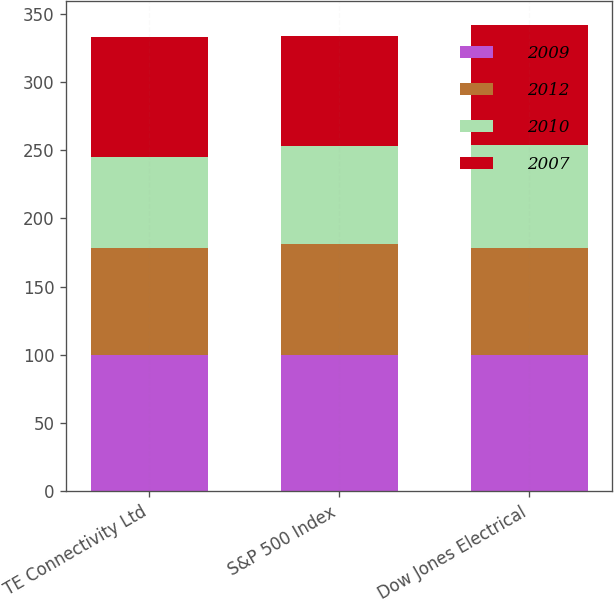Convert chart to OTSL. <chart><loc_0><loc_0><loc_500><loc_500><stacked_bar_chart><ecel><fcel>TE Connectivity Ltd<fcel>S&P 500 Index<fcel>Dow Jones Electrical<nl><fcel>2009<fcel>100<fcel>100<fcel>100<nl><fcel>2012<fcel>78.25<fcel>81.14<fcel>78.1<nl><fcel>2010<fcel>66.79<fcel>71.74<fcel>75.77<nl><fcel>2007<fcel>87.65<fcel>80.51<fcel>88.09<nl></chart> 